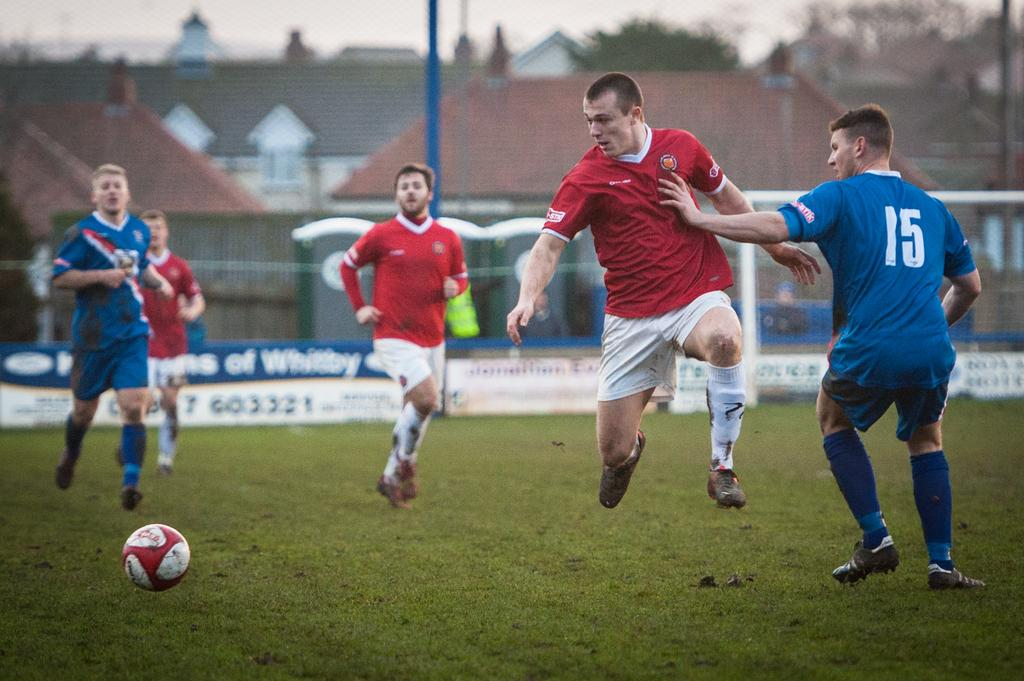<image>
Offer a succinct explanation of the picture presented. Player number 15 in blue blocks his opponent from the ball near a sign for Whitby's 